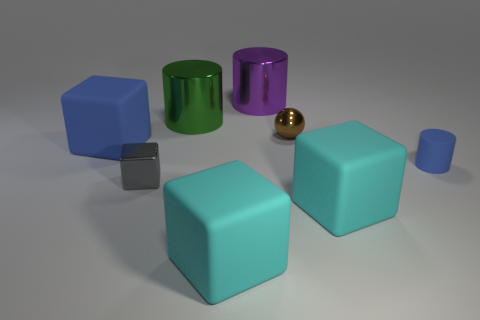The block that is the same color as the tiny cylinder is what size?
Your answer should be compact. Large. Are there any big blocks of the same color as the small matte cylinder?
Keep it short and to the point. Yes. There is a gray block that is the same material as the brown sphere; what is its size?
Your answer should be compact. Small. The big matte object behind the metallic object that is in front of the blue thing to the left of the green thing is what shape?
Offer a very short reply. Cube. The blue object that is the same shape as the small gray object is what size?
Your response must be concise. Large. What is the size of the rubber object that is both left of the small matte cylinder and on the right side of the purple metallic thing?
Give a very brief answer. Large. The large object that is the same color as the small rubber object is what shape?
Provide a short and direct response. Cube. What color is the matte cylinder?
Make the answer very short. Blue. How big is the blue matte thing on the left side of the tiny blue matte thing?
Offer a very short reply. Large. What number of metal cylinders are in front of the big blue thing behind the large cyan cube that is on the left side of the ball?
Your response must be concise. 0. 